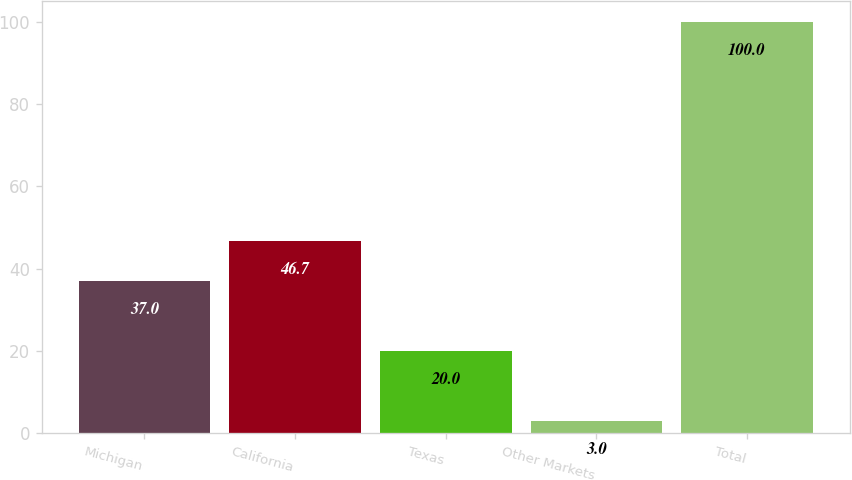Convert chart. <chart><loc_0><loc_0><loc_500><loc_500><bar_chart><fcel>Michigan<fcel>California<fcel>Texas<fcel>Other Markets<fcel>Total<nl><fcel>37<fcel>46.7<fcel>20<fcel>3<fcel>100<nl></chart> 